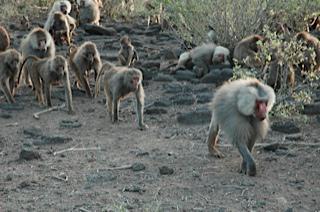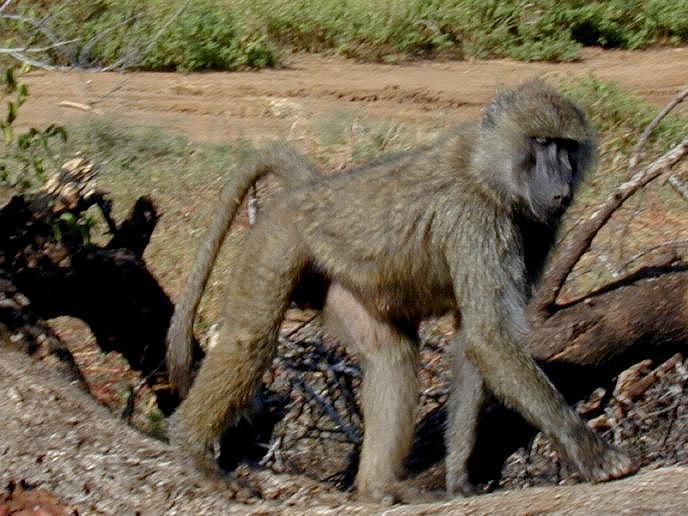The first image is the image on the left, the second image is the image on the right. Assess this claim about the two images: "Multiple baboons sit on tiered rocks in at least one image.". Correct or not? Answer yes or no. No. The first image is the image on the left, the second image is the image on the right. For the images shown, is this caption "One of the images contains no more than five monkeys" true? Answer yes or no. Yes. 